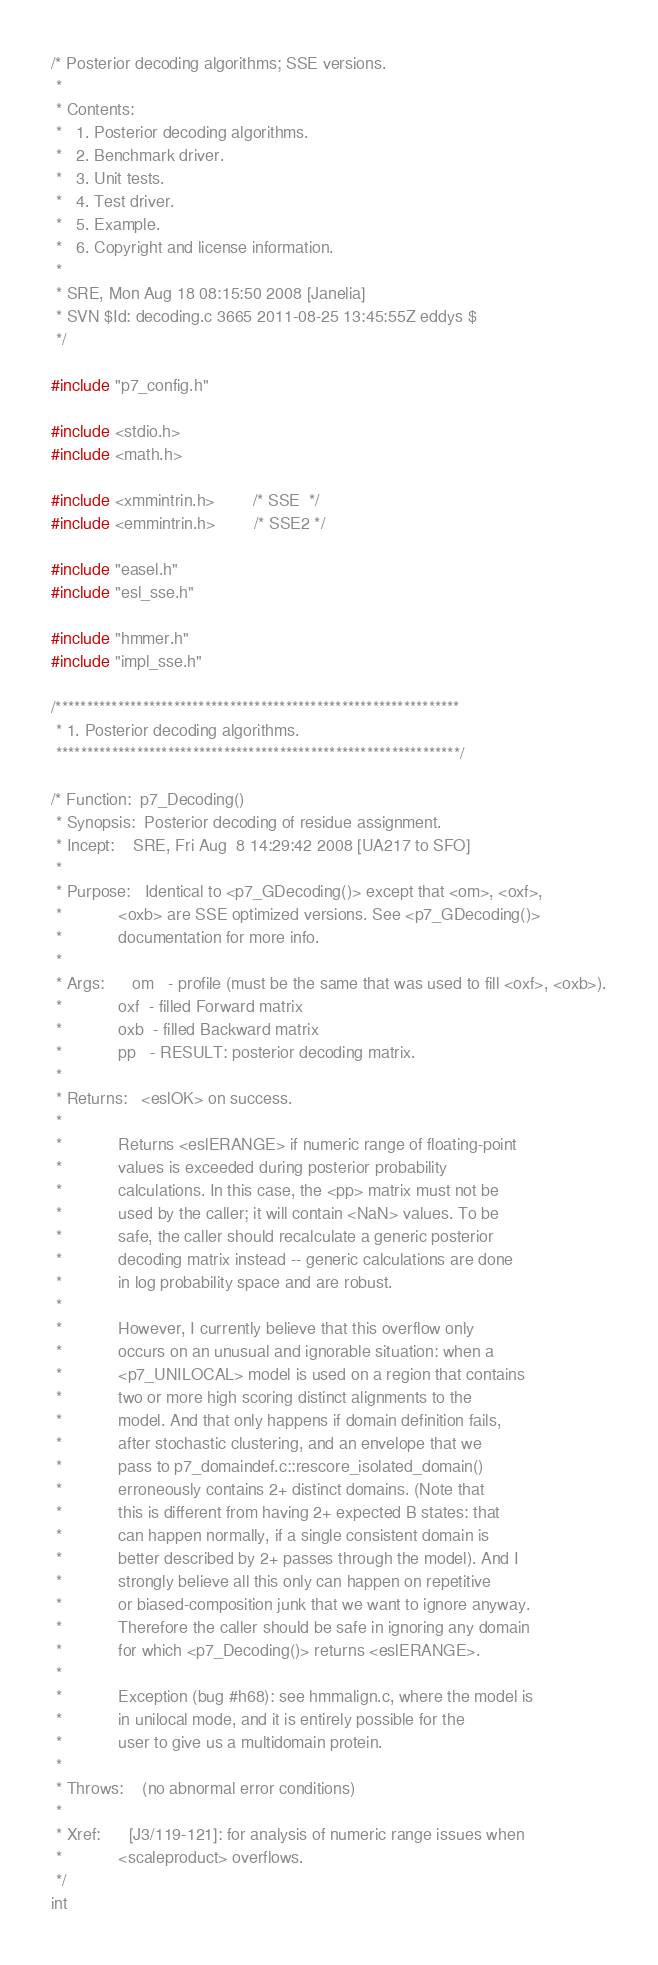Convert code to text. <code><loc_0><loc_0><loc_500><loc_500><_C_>/* Posterior decoding algorithms; SSE versions.
 * 
 * Contents:
 *   1. Posterior decoding algorithms.
 *   2. Benchmark driver.
 *   3. Unit tests.
 *   4. Test driver.
 *   5. Example.
 *   6. Copyright and license information.
 *   
 * SRE, Mon Aug 18 08:15:50 2008 [Janelia]
 * SVN $Id: decoding.c 3665 2011-08-25 13:45:55Z eddys $
 */

#include "p7_config.h"

#include <stdio.h>
#include <math.h>

#include <xmmintrin.h>		/* SSE  */
#include <emmintrin.h>		/* SSE2 */

#include "easel.h"
#include "esl_sse.h"

#include "hmmer.h"
#include "impl_sse.h"

/*****************************************************************
 * 1. Posterior decoding algorithms.
 *****************************************************************/

/* Function:  p7_Decoding()
 * Synopsis:  Posterior decoding of residue assignment.
 * Incept:    SRE, Fri Aug  8 14:29:42 2008 [UA217 to SFO]
 *
 * Purpose:   Identical to <p7_GDecoding()> except that <om>, <oxf>,
 *            <oxb> are SSE optimized versions. See <p7_GDecoding()>
 *            documentation for more info.
 *
 * Args:      om   - profile (must be the same that was used to fill <oxf>, <oxb>).
 *            oxf  - filled Forward matrix 
 *            oxb  - filled Backward matrix
 *            pp   - RESULT: posterior decoding matrix.
 *
 * Returns:   <eslOK> on success.
 *            
 *            Returns <eslERANGE> if numeric range of floating-point
 *            values is exceeded during posterior probability
 *            calculations. In this case, the <pp> matrix must not be
 *            used by the caller; it will contain <NaN> values. To be
 *            safe, the caller should recalculate a generic posterior
 *            decoding matrix instead -- generic calculations are done
 *            in log probability space and are robust. 
 *            
 *            However, I currently believe that this overflow only
 *            occurs on an unusual and ignorable situation: when a
 *            <p7_UNILOCAL> model is used on a region that contains
 *            two or more high scoring distinct alignments to the
 *            model. And that only happens if domain definition fails,
 *            after stochastic clustering, and an envelope that we
 *            pass to p7_domaindef.c::rescore_isolated_domain()
 *            erroneously contains 2+ distinct domains. (Note that
 *            this is different from having 2+ expected B states: that
 *            can happen normally, if a single consistent domain is
 *            better described by 2+ passes through the model). And I
 *            strongly believe all this only can happen on repetitive
 *            or biased-composition junk that we want to ignore anyway.
 *            Therefore the caller should be safe in ignoring any domain
 *            for which <p7_Decoding()> returns <eslERANGE>.
 *            
 *            Exception (bug #h68): see hmmalign.c, where the model is
 *            in unilocal mode, and it is entirely possible for the
 *            user to give us a multidomain protein.
 *
 * Throws:    (no abnormal error conditions)
 * 
 * Xref:      [J3/119-121]: for analysis of numeric range issues when
 *            <scaleproduct> overflows.
 */
int</code> 